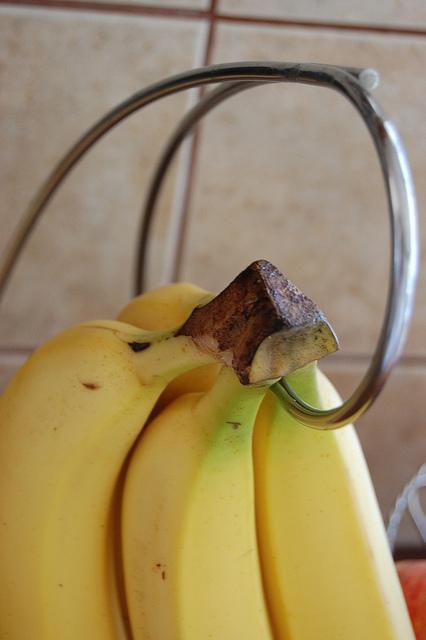How many bananas are in the picture?
Be succinct. 4. What color is the grout?
Quick response, please. Brown. Have the spots on these bananas been there for longer than a day?
Write a very short answer. No. Are the bananas ripe enough to eat?
Answer briefly. Yes. 